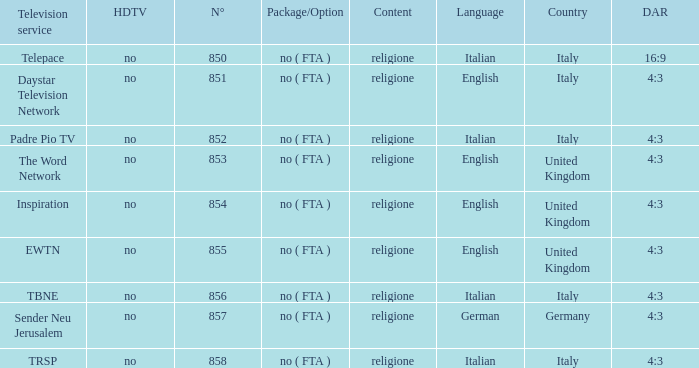Could you help me parse every detail presented in this table? {'header': ['Television service', 'HDTV', 'N°', 'Package/Option', 'Content', 'Language', 'Country', 'DAR'], 'rows': [['Telepace', 'no', '850', 'no ( FTA )', 'religione', 'Italian', 'Italy', '16:9'], ['Daystar Television Network', 'no', '851', 'no ( FTA )', 'religione', 'English', 'Italy', '4:3'], ['Padre Pio TV', 'no', '852', 'no ( FTA )', 'religione', 'Italian', 'Italy', '4:3'], ['The Word Network', 'no', '853', 'no ( FTA )', 'religione', 'English', 'United Kingdom', '4:3'], ['Inspiration', 'no', '854', 'no ( FTA )', 'religione', 'English', 'United Kingdom', '4:3'], ['EWTN', 'no', '855', 'no ( FTA )', 'religione', 'English', 'United Kingdom', '4:3'], ['TBNE', 'no', '856', 'no ( FTA )', 'religione', 'Italian', 'Italy', '4:3'], ['Sender Neu Jerusalem', 'no', '857', 'no ( FTA )', 'religione', 'German', 'Germany', '4:3'], ['TRSP', 'no', '858', 'no ( FTA )', 'religione', 'Italian', 'Italy', '4:3']]} How many dar are in germany? 4:3. 